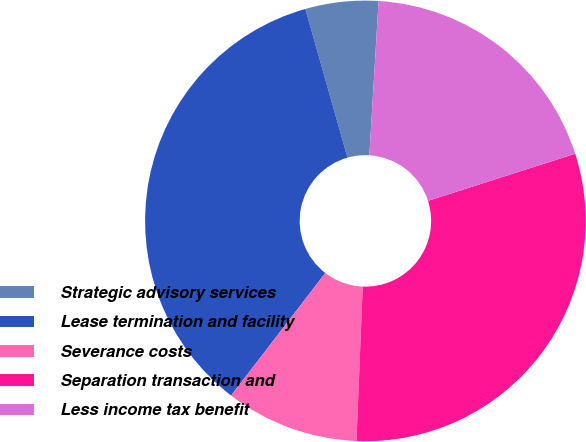<chart> <loc_0><loc_0><loc_500><loc_500><pie_chart><fcel>Strategic advisory services<fcel>Lease termination and facility<fcel>Severance costs<fcel>Separation transaction and<fcel>Less income tax benefit<nl><fcel>5.35%<fcel>35.17%<fcel>9.79%<fcel>30.58%<fcel>19.11%<nl></chart> 